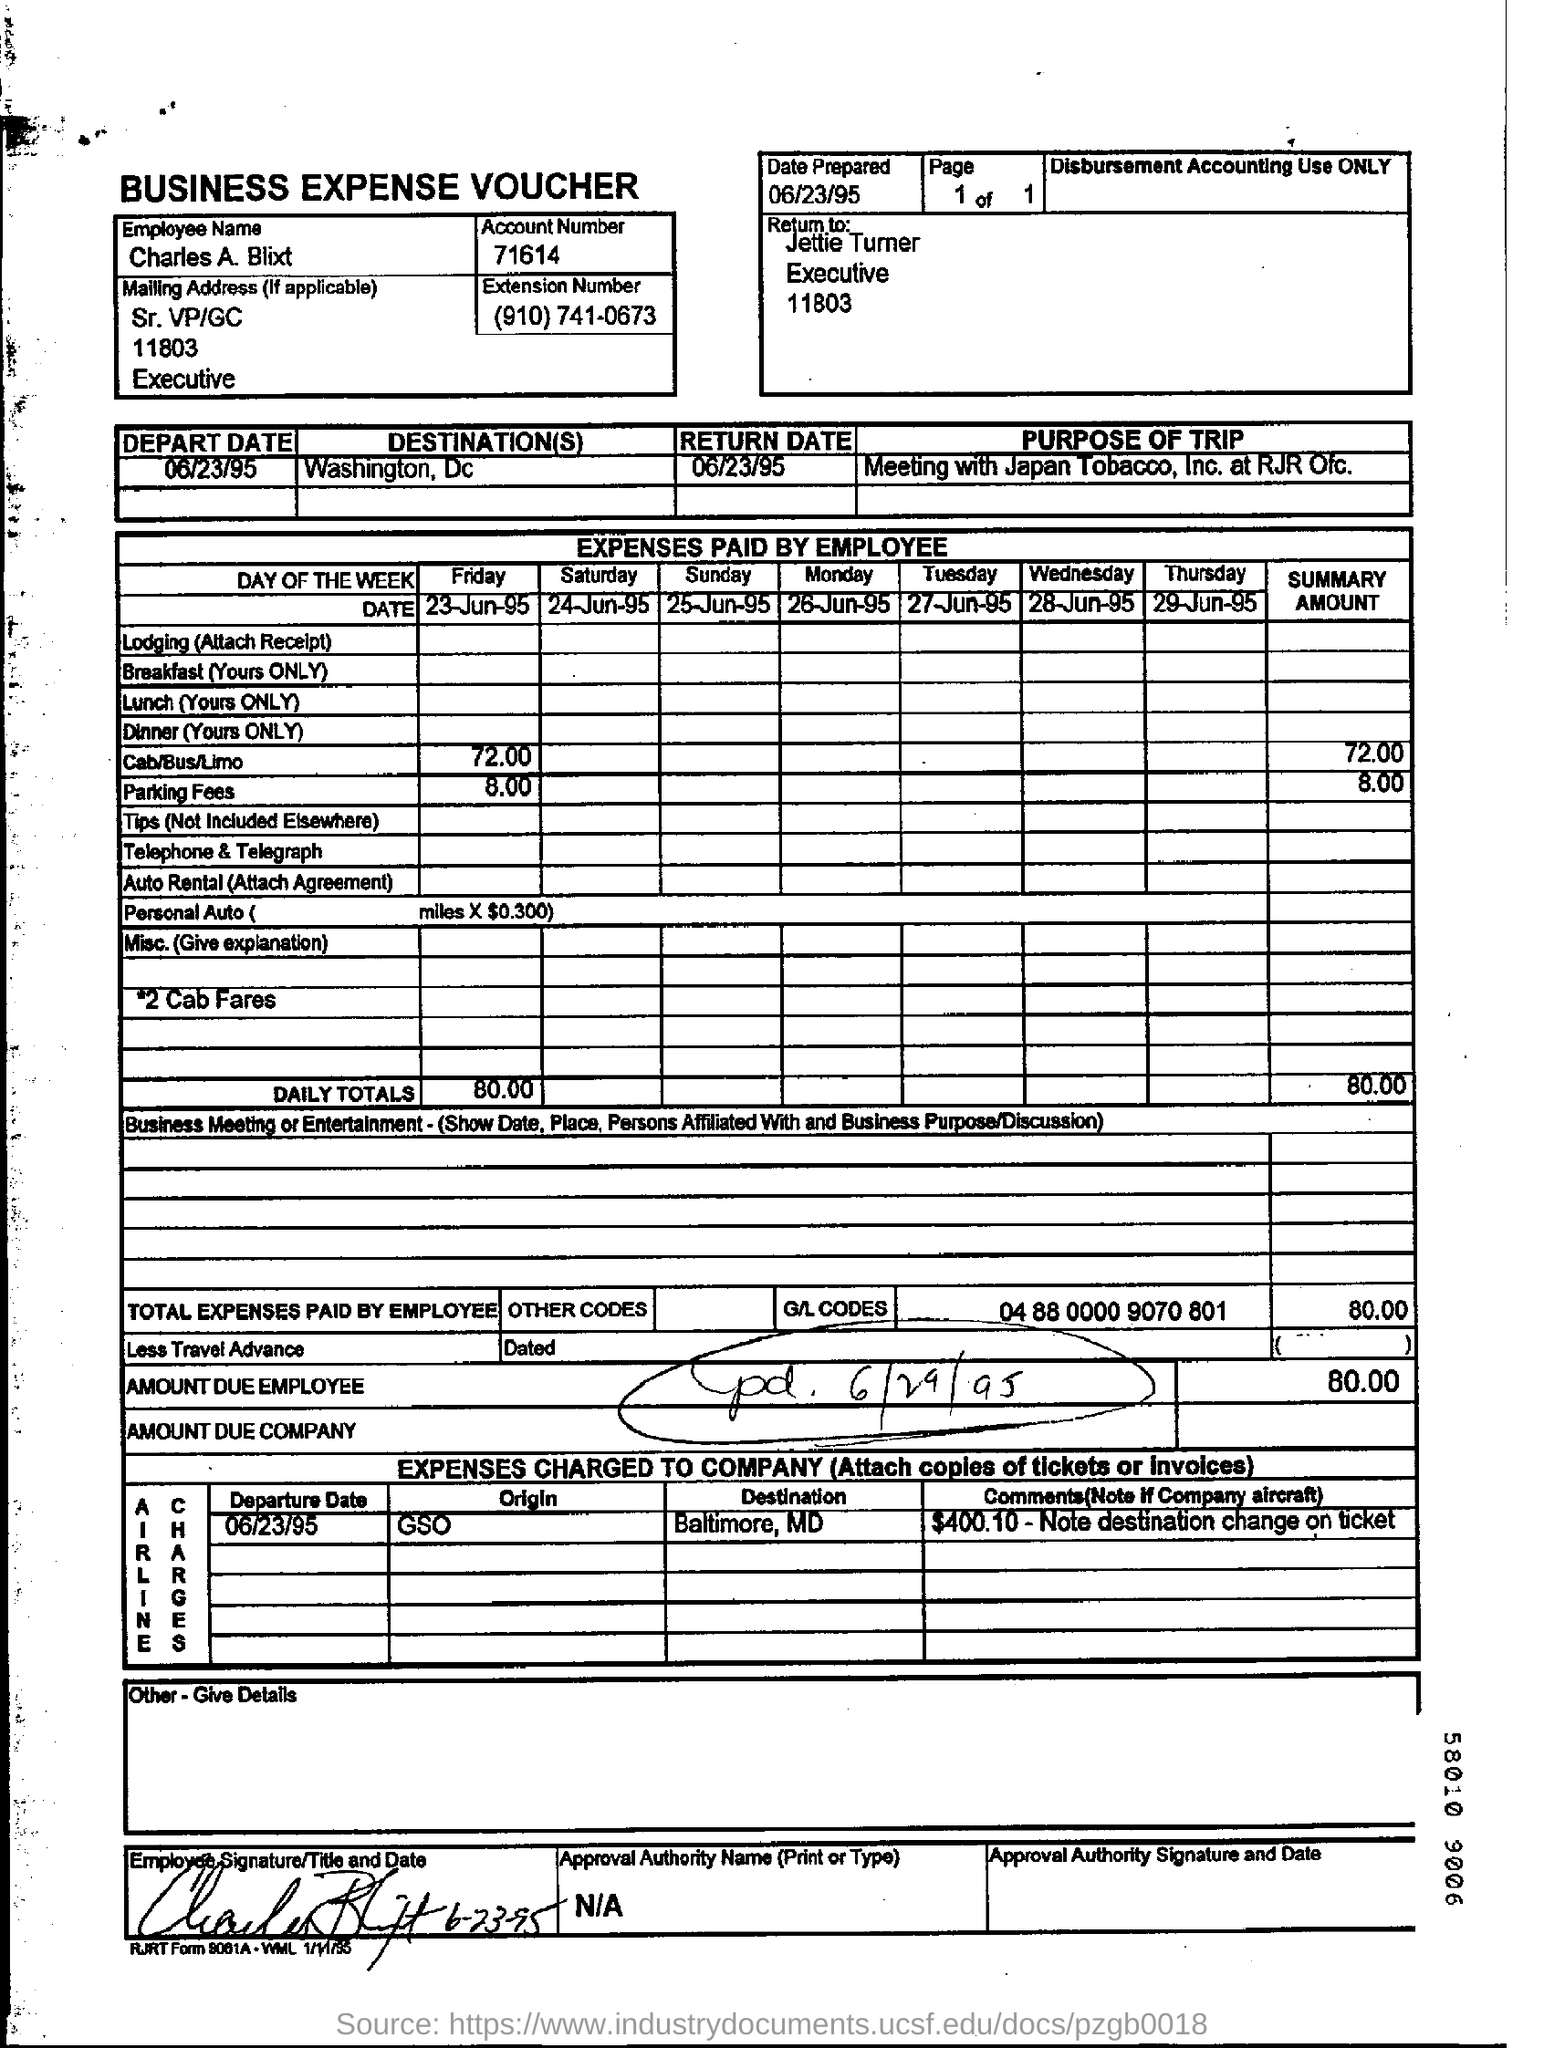Point out several critical features in this image. The employee whose name is mentioned in the business expense voucher is Charles A. Blixt. The business expense voucher contains the account number 71614. The due amount by the employee is 80.00. The voucher indicates that the employee's name is Charles A. Blixt. The employee paid $8.00 for parking fees. 